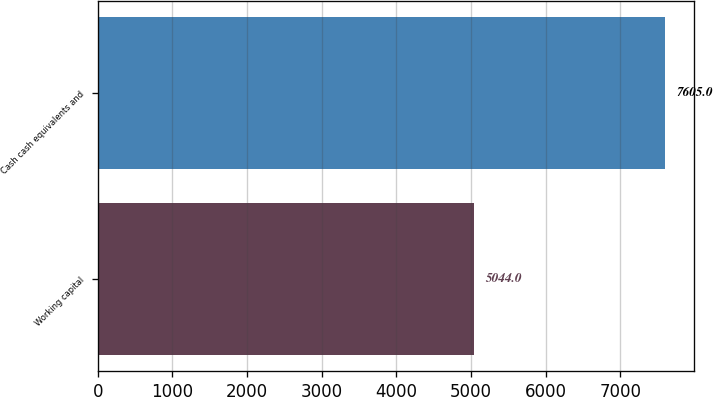<chart> <loc_0><loc_0><loc_500><loc_500><bar_chart><fcel>Working capital<fcel>Cash cash equivalents and<nl><fcel>5044<fcel>7605<nl></chart> 